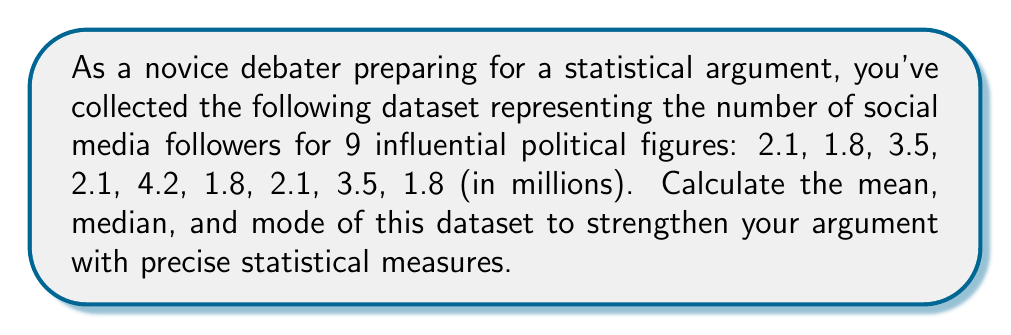Can you solve this math problem? 1. Calculate the mean:
   $\text{Mean} = \frac{\text{Sum of all values}}{\text{Number of values}}$
   
   Sum: $2.1 + 1.8 + 3.5 + 2.1 + 4.2 + 1.8 + 2.1 + 3.5 + 1.8 = 22.9$
   Number of values: 9
   
   $\text{Mean} = \frac{22.9}{9} = 2.544$ million followers

2. Find the median:
   First, arrange the data in ascending order:
   1.8, 1.8, 1.8, 2.1, 2.1, 2.1, 3.5, 3.5, 4.2
   
   With 9 values, the median is the 5th value (middle number).
   $\text{Median} = 2.1$ million followers

3. Determine the mode:
   Count the frequency of each value:
   1.8 appears 3 times
   2.1 appears 3 times
   3.5 appears 2 times
   4.2 appears 1 time
   
   The mode is the value(s) that appear most frequently. In this case, there are two modes:
   $\text{Mode} = 1.8$ and $2.1$ million followers
Answer: Mean: 2.544 million, Median: 2.1 million, Mode: 1.8 and 2.1 million 